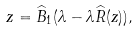Convert formula to latex. <formula><loc_0><loc_0><loc_500><loc_500>z = \widehat { B } _ { 1 } ( \lambda - \lambda \widehat { R } ( z ) ) ,</formula> 